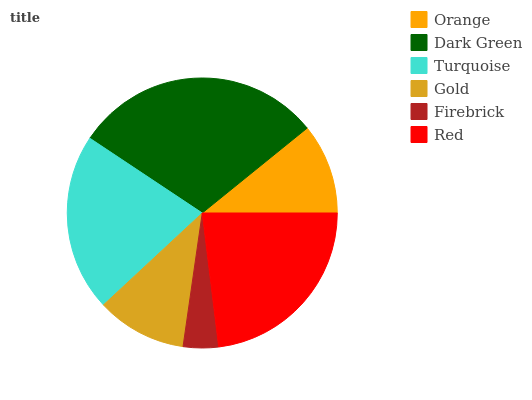Is Firebrick the minimum?
Answer yes or no. Yes. Is Dark Green the maximum?
Answer yes or no. Yes. Is Turquoise the minimum?
Answer yes or no. No. Is Turquoise the maximum?
Answer yes or no. No. Is Dark Green greater than Turquoise?
Answer yes or no. Yes. Is Turquoise less than Dark Green?
Answer yes or no. Yes. Is Turquoise greater than Dark Green?
Answer yes or no. No. Is Dark Green less than Turquoise?
Answer yes or no. No. Is Turquoise the high median?
Answer yes or no. Yes. Is Orange the low median?
Answer yes or no. Yes. Is Gold the high median?
Answer yes or no. No. Is Red the low median?
Answer yes or no. No. 